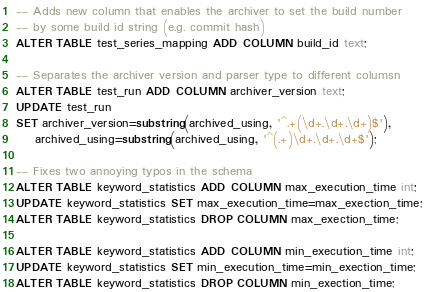Convert code to text. <code><loc_0><loc_0><loc_500><loc_500><_SQL_>-- Adds new column that enables the archiver to set the build number
-- by some build id string (e.g. commit hash)
ALTER TABLE test_series_mapping ADD COLUMN build_id text;

-- Separates the archiver version and parser type to different columsn
ALTER TABLE test_run ADD COLUMN archiver_version text;
UPDATE test_run
SET archiver_version=substring(archived_using, '^.+(\d+.\d+.\d+)$'),
    archived_using=substring(archived_using, '^(.+)\d+.\d+.\d+$');

-- Fixes two annoying typos in the schema
ALTER TABLE keyword_statistics ADD COLUMN max_execution_time int;
UPDATE keyword_statistics SET max_execution_time=max_exection_time;
ALTER TABLE keyword_statistics DROP COLUMN max_exection_time;

ALTER TABLE keyword_statistics ADD COLUMN min_execution_time int;
UPDATE keyword_statistics SET min_execution_time=min_exection_time;
ALTER TABLE keyword_statistics DROP COLUMN min_exection_time;
</code> 